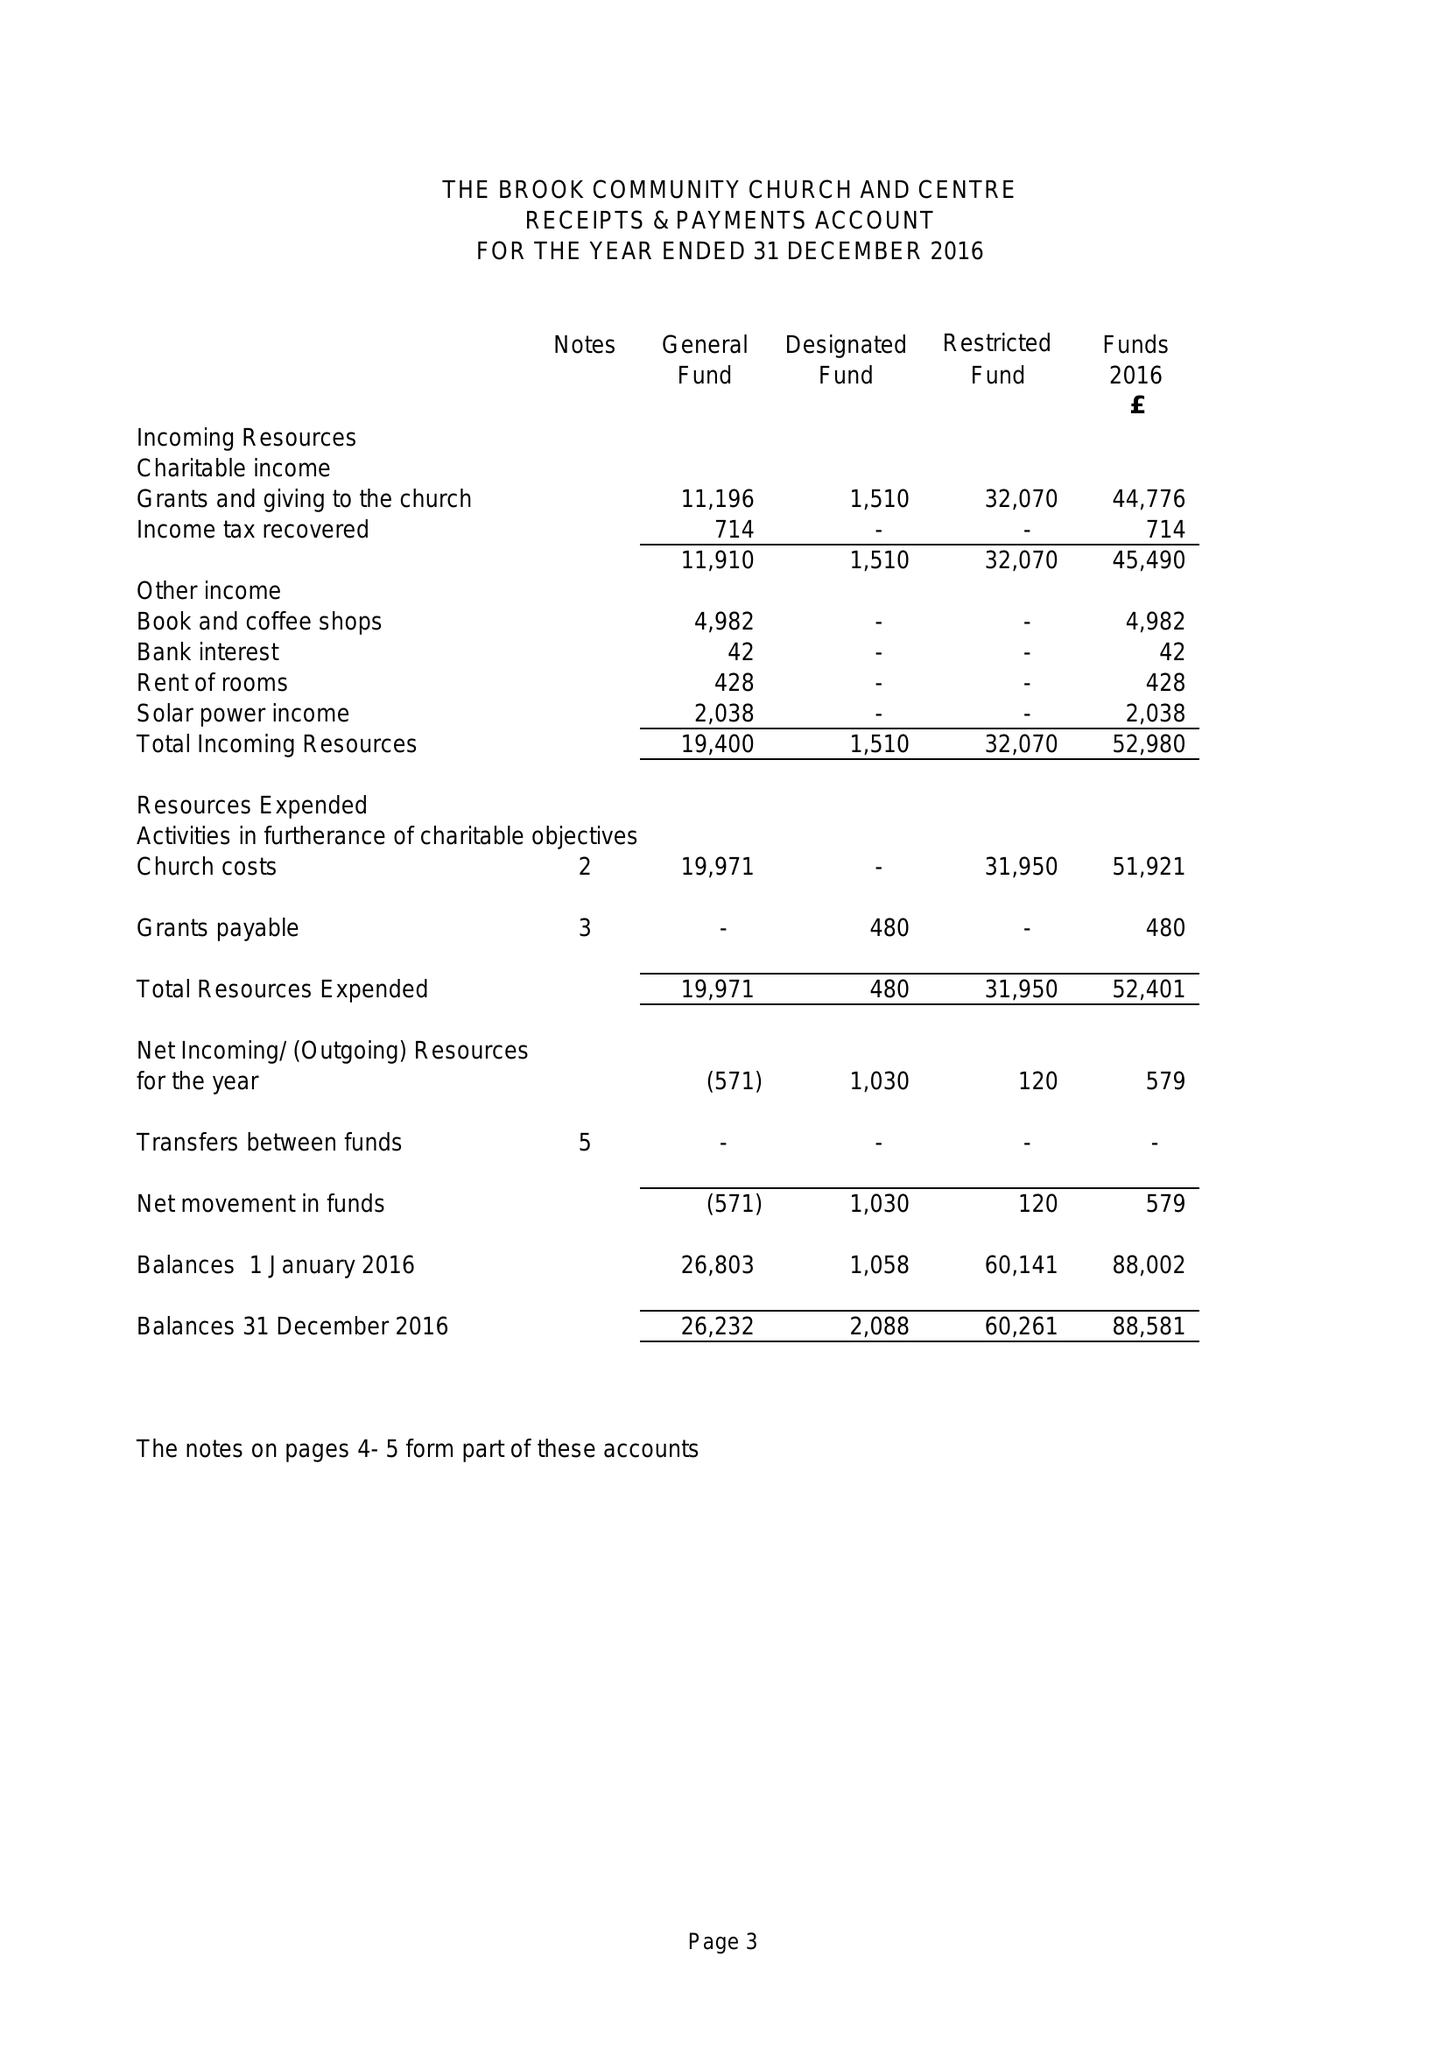What is the value for the address__postcode?
Answer the question using a single word or phrase. NG20 8DG 